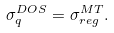Convert formula to latex. <formula><loc_0><loc_0><loc_500><loc_500>\sigma ^ { D O S } _ { q } = \sigma ^ { M T } _ { r e g } .</formula> 